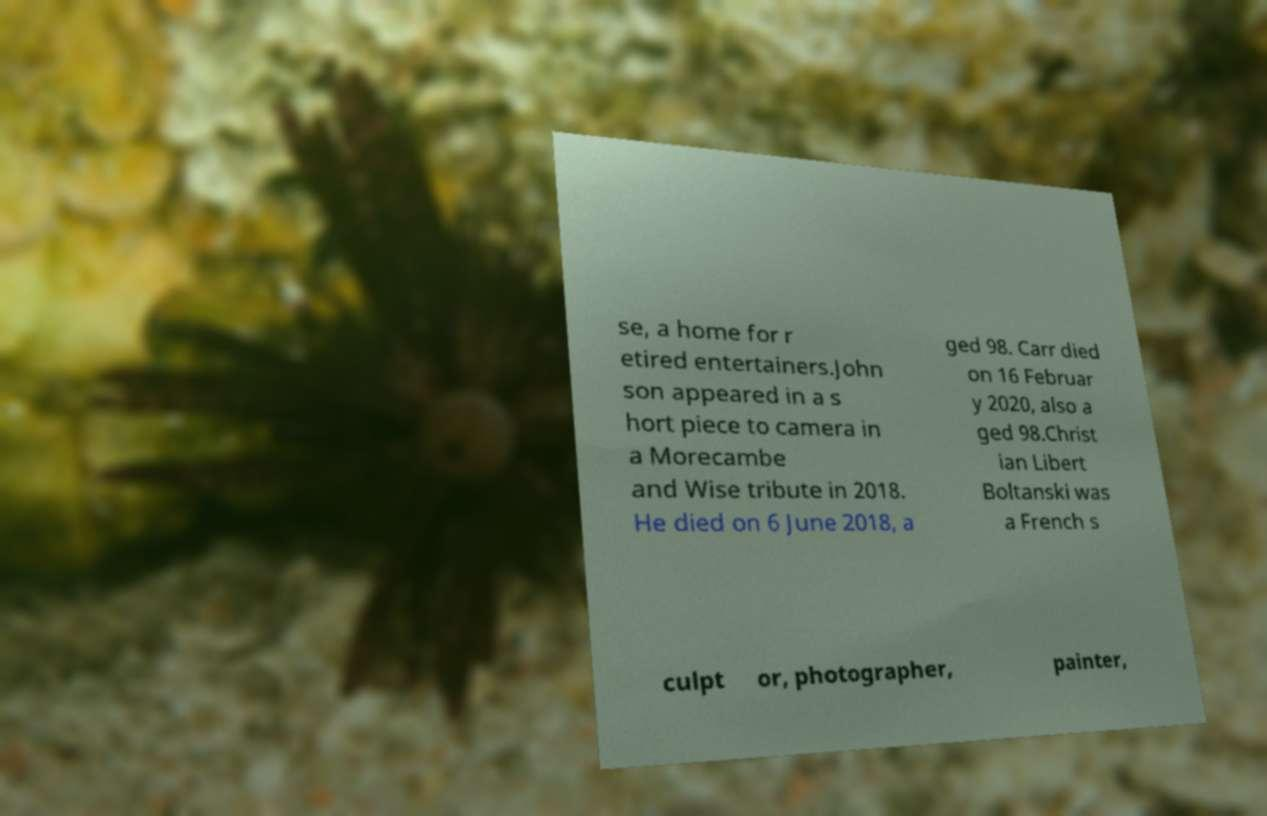Could you extract and type out the text from this image? se, a home for r etired entertainers.John son appeared in a s hort piece to camera in a Morecambe and Wise tribute in 2018. He died on 6 June 2018, a ged 98. Carr died on 16 Februar y 2020, also a ged 98.Christ ian Libert Boltanski was a French s culpt or, photographer, painter, 